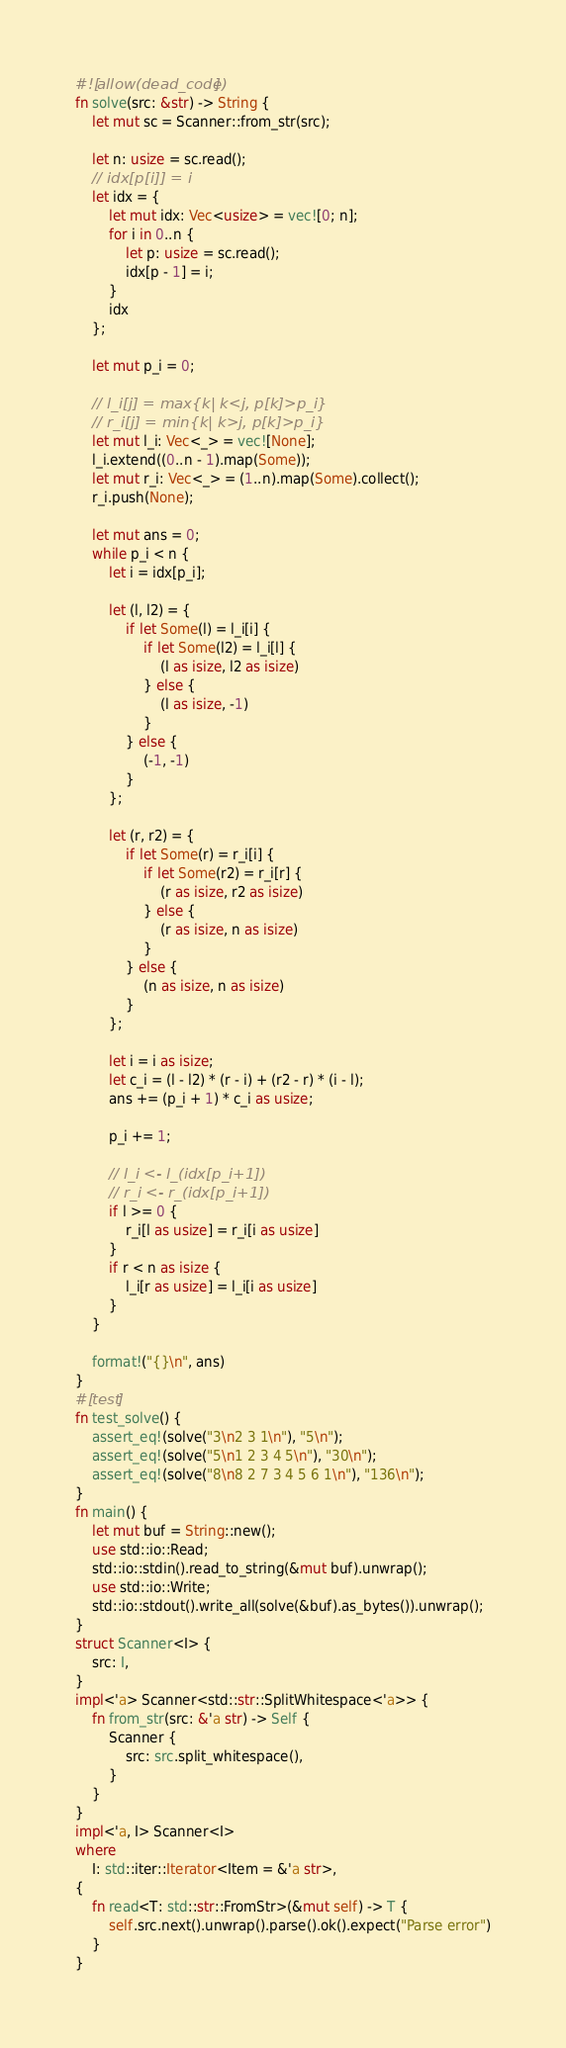<code> <loc_0><loc_0><loc_500><loc_500><_Rust_>#![allow(dead_code)]
fn solve(src: &str) -> String {
    let mut sc = Scanner::from_str(src);

    let n: usize = sc.read();
    // idx[p[i]] = i
    let idx = {
        let mut idx: Vec<usize> = vec![0; n];
        for i in 0..n {
            let p: usize = sc.read();
            idx[p - 1] = i;
        }
        idx
    };

    let mut p_i = 0;

    // l_i[j] = max{k| k<j, p[k]>p_i}
    // r_i[j] = min{k| k>j, p[k]>p_i}
    let mut l_i: Vec<_> = vec![None];
    l_i.extend((0..n - 1).map(Some));
    let mut r_i: Vec<_> = (1..n).map(Some).collect();
    r_i.push(None);

    let mut ans = 0;
    while p_i < n {
        let i = idx[p_i];

        let (l, l2) = {
            if let Some(l) = l_i[i] {
                if let Some(l2) = l_i[l] {
                    (l as isize, l2 as isize)
                } else {
                    (l as isize, -1)
                }
            } else {
                (-1, -1)
            }
        };

        let (r, r2) = {
            if let Some(r) = r_i[i] {
                if let Some(r2) = r_i[r] {
                    (r as isize, r2 as isize)
                } else {
                    (r as isize, n as isize)
                }
            } else {
                (n as isize, n as isize)
            }
        };

        let i = i as isize;
        let c_i = (l - l2) * (r - i) + (r2 - r) * (i - l);
        ans += (p_i + 1) * c_i as usize;

        p_i += 1;

        // l_i <- l_(idx[p_i+1])
        // r_i <- r_(idx[p_i+1])
        if l >= 0 {
            r_i[l as usize] = r_i[i as usize]
        }
        if r < n as isize {
            l_i[r as usize] = l_i[i as usize]
        }
    }

    format!("{}\n", ans)
}
#[test]
fn test_solve() {
    assert_eq!(solve("3\n2 3 1\n"), "5\n");
    assert_eq!(solve("5\n1 2 3 4 5\n"), "30\n");
    assert_eq!(solve("8\n8 2 7 3 4 5 6 1\n"), "136\n");
}
fn main() {
    let mut buf = String::new();
    use std::io::Read;
    std::io::stdin().read_to_string(&mut buf).unwrap();
    use std::io::Write;
    std::io::stdout().write_all(solve(&buf).as_bytes()).unwrap();
}
struct Scanner<I> {
    src: I,
}
impl<'a> Scanner<std::str::SplitWhitespace<'a>> {
    fn from_str(src: &'a str) -> Self {
        Scanner {
            src: src.split_whitespace(),
        }
    }
}
impl<'a, I> Scanner<I>
where
    I: std::iter::Iterator<Item = &'a str>,
{
    fn read<T: std::str::FromStr>(&mut self) -> T {
        self.src.next().unwrap().parse().ok().expect("Parse error")
    }
}
</code> 